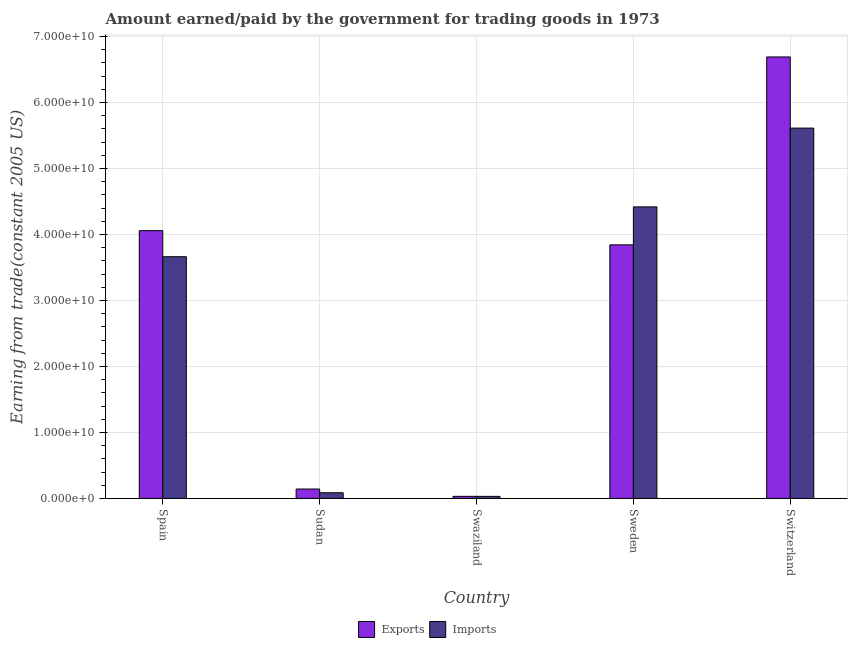How many different coloured bars are there?
Keep it short and to the point. 2. Are the number of bars per tick equal to the number of legend labels?
Keep it short and to the point. Yes. Are the number of bars on each tick of the X-axis equal?
Give a very brief answer. Yes. How many bars are there on the 4th tick from the left?
Make the answer very short. 2. What is the label of the 3rd group of bars from the left?
Offer a terse response. Swaziland. What is the amount earned from exports in Sweden?
Ensure brevity in your answer.  3.84e+1. Across all countries, what is the maximum amount earned from exports?
Your response must be concise. 6.69e+1. Across all countries, what is the minimum amount paid for imports?
Provide a short and direct response. 3.14e+08. In which country was the amount earned from exports maximum?
Offer a terse response. Switzerland. In which country was the amount earned from exports minimum?
Your answer should be very brief. Swaziland. What is the total amount earned from exports in the graph?
Your answer should be very brief. 1.48e+11. What is the difference between the amount earned from exports in Sweden and that in Switzerland?
Provide a short and direct response. -2.85e+1. What is the difference between the amount earned from exports in Sudan and the amount paid for imports in Switzerland?
Give a very brief answer. -5.47e+1. What is the average amount earned from exports per country?
Keep it short and to the point. 2.95e+1. What is the difference between the amount paid for imports and amount earned from exports in Spain?
Your response must be concise. -3.95e+09. In how many countries, is the amount paid for imports greater than 58000000000 US$?
Your answer should be very brief. 0. What is the ratio of the amount paid for imports in Sudan to that in Swaziland?
Give a very brief answer. 2.74. What is the difference between the highest and the second highest amount earned from exports?
Make the answer very short. 2.63e+1. What is the difference between the highest and the lowest amount paid for imports?
Your response must be concise. 5.58e+1. Is the sum of the amount paid for imports in Spain and Sudan greater than the maximum amount earned from exports across all countries?
Your answer should be very brief. No. What does the 1st bar from the left in Sudan represents?
Ensure brevity in your answer.  Exports. What does the 1st bar from the right in Sudan represents?
Ensure brevity in your answer.  Imports. How many bars are there?
Make the answer very short. 10. Are all the bars in the graph horizontal?
Give a very brief answer. No. Does the graph contain any zero values?
Provide a short and direct response. No. Where does the legend appear in the graph?
Provide a succinct answer. Bottom center. How are the legend labels stacked?
Offer a very short reply. Horizontal. What is the title of the graph?
Offer a terse response. Amount earned/paid by the government for trading goods in 1973. Does "Quasi money growth" appear as one of the legend labels in the graph?
Your answer should be very brief. No. What is the label or title of the X-axis?
Your answer should be compact. Country. What is the label or title of the Y-axis?
Your answer should be very brief. Earning from trade(constant 2005 US). What is the Earning from trade(constant 2005 US) in Exports in Spain?
Ensure brevity in your answer.  4.06e+1. What is the Earning from trade(constant 2005 US) of Imports in Spain?
Provide a succinct answer. 3.66e+1. What is the Earning from trade(constant 2005 US) of Exports in Sudan?
Your response must be concise. 1.43e+09. What is the Earning from trade(constant 2005 US) of Imports in Sudan?
Keep it short and to the point. 8.62e+08. What is the Earning from trade(constant 2005 US) in Exports in Swaziland?
Your answer should be very brief. 3.16e+08. What is the Earning from trade(constant 2005 US) in Imports in Swaziland?
Provide a succinct answer. 3.14e+08. What is the Earning from trade(constant 2005 US) in Exports in Sweden?
Offer a terse response. 3.84e+1. What is the Earning from trade(constant 2005 US) in Imports in Sweden?
Offer a very short reply. 4.42e+1. What is the Earning from trade(constant 2005 US) of Exports in Switzerland?
Your response must be concise. 6.69e+1. What is the Earning from trade(constant 2005 US) in Imports in Switzerland?
Ensure brevity in your answer.  5.61e+1. Across all countries, what is the maximum Earning from trade(constant 2005 US) of Exports?
Your response must be concise. 6.69e+1. Across all countries, what is the maximum Earning from trade(constant 2005 US) of Imports?
Ensure brevity in your answer.  5.61e+1. Across all countries, what is the minimum Earning from trade(constant 2005 US) of Exports?
Keep it short and to the point. 3.16e+08. Across all countries, what is the minimum Earning from trade(constant 2005 US) of Imports?
Your answer should be very brief. 3.14e+08. What is the total Earning from trade(constant 2005 US) of Exports in the graph?
Your answer should be very brief. 1.48e+11. What is the total Earning from trade(constant 2005 US) in Imports in the graph?
Offer a terse response. 1.38e+11. What is the difference between the Earning from trade(constant 2005 US) in Exports in Spain and that in Sudan?
Provide a short and direct response. 3.92e+1. What is the difference between the Earning from trade(constant 2005 US) of Imports in Spain and that in Sudan?
Offer a terse response. 3.58e+1. What is the difference between the Earning from trade(constant 2005 US) in Exports in Spain and that in Swaziland?
Your response must be concise. 4.03e+1. What is the difference between the Earning from trade(constant 2005 US) in Imports in Spain and that in Swaziland?
Make the answer very short. 3.63e+1. What is the difference between the Earning from trade(constant 2005 US) in Exports in Spain and that in Sweden?
Provide a succinct answer. 2.15e+09. What is the difference between the Earning from trade(constant 2005 US) of Imports in Spain and that in Sweden?
Ensure brevity in your answer.  -7.56e+09. What is the difference between the Earning from trade(constant 2005 US) in Exports in Spain and that in Switzerland?
Your answer should be compact. -2.63e+1. What is the difference between the Earning from trade(constant 2005 US) of Imports in Spain and that in Switzerland?
Ensure brevity in your answer.  -1.95e+1. What is the difference between the Earning from trade(constant 2005 US) in Exports in Sudan and that in Swaziland?
Provide a short and direct response. 1.11e+09. What is the difference between the Earning from trade(constant 2005 US) in Imports in Sudan and that in Swaziland?
Give a very brief answer. 5.48e+08. What is the difference between the Earning from trade(constant 2005 US) of Exports in Sudan and that in Sweden?
Your answer should be very brief. -3.70e+1. What is the difference between the Earning from trade(constant 2005 US) in Imports in Sudan and that in Sweden?
Keep it short and to the point. -4.33e+1. What is the difference between the Earning from trade(constant 2005 US) of Exports in Sudan and that in Switzerland?
Offer a terse response. -6.55e+1. What is the difference between the Earning from trade(constant 2005 US) of Imports in Sudan and that in Switzerland?
Give a very brief answer. -5.53e+1. What is the difference between the Earning from trade(constant 2005 US) of Exports in Swaziland and that in Sweden?
Keep it short and to the point. -3.81e+1. What is the difference between the Earning from trade(constant 2005 US) of Imports in Swaziland and that in Sweden?
Your answer should be very brief. -4.39e+1. What is the difference between the Earning from trade(constant 2005 US) of Exports in Swaziland and that in Switzerland?
Make the answer very short. -6.66e+1. What is the difference between the Earning from trade(constant 2005 US) of Imports in Swaziland and that in Switzerland?
Your answer should be very brief. -5.58e+1. What is the difference between the Earning from trade(constant 2005 US) in Exports in Sweden and that in Switzerland?
Provide a short and direct response. -2.85e+1. What is the difference between the Earning from trade(constant 2005 US) in Imports in Sweden and that in Switzerland?
Your answer should be compact. -1.19e+1. What is the difference between the Earning from trade(constant 2005 US) of Exports in Spain and the Earning from trade(constant 2005 US) of Imports in Sudan?
Your answer should be compact. 3.97e+1. What is the difference between the Earning from trade(constant 2005 US) in Exports in Spain and the Earning from trade(constant 2005 US) in Imports in Swaziland?
Provide a short and direct response. 4.03e+1. What is the difference between the Earning from trade(constant 2005 US) of Exports in Spain and the Earning from trade(constant 2005 US) of Imports in Sweden?
Offer a very short reply. -3.60e+09. What is the difference between the Earning from trade(constant 2005 US) in Exports in Spain and the Earning from trade(constant 2005 US) in Imports in Switzerland?
Your answer should be very brief. -1.55e+1. What is the difference between the Earning from trade(constant 2005 US) in Exports in Sudan and the Earning from trade(constant 2005 US) in Imports in Swaziland?
Your answer should be compact. 1.11e+09. What is the difference between the Earning from trade(constant 2005 US) of Exports in Sudan and the Earning from trade(constant 2005 US) of Imports in Sweden?
Offer a very short reply. -4.28e+1. What is the difference between the Earning from trade(constant 2005 US) in Exports in Sudan and the Earning from trade(constant 2005 US) in Imports in Switzerland?
Give a very brief answer. -5.47e+1. What is the difference between the Earning from trade(constant 2005 US) in Exports in Swaziland and the Earning from trade(constant 2005 US) in Imports in Sweden?
Give a very brief answer. -4.39e+1. What is the difference between the Earning from trade(constant 2005 US) of Exports in Swaziland and the Earning from trade(constant 2005 US) of Imports in Switzerland?
Make the answer very short. -5.58e+1. What is the difference between the Earning from trade(constant 2005 US) in Exports in Sweden and the Earning from trade(constant 2005 US) in Imports in Switzerland?
Keep it short and to the point. -1.77e+1. What is the average Earning from trade(constant 2005 US) in Exports per country?
Offer a terse response. 2.95e+1. What is the average Earning from trade(constant 2005 US) of Imports per country?
Ensure brevity in your answer.  2.76e+1. What is the difference between the Earning from trade(constant 2005 US) in Exports and Earning from trade(constant 2005 US) in Imports in Spain?
Offer a very short reply. 3.95e+09. What is the difference between the Earning from trade(constant 2005 US) of Exports and Earning from trade(constant 2005 US) of Imports in Sudan?
Your response must be concise. 5.64e+08. What is the difference between the Earning from trade(constant 2005 US) in Exports and Earning from trade(constant 2005 US) in Imports in Swaziland?
Your response must be concise. 2.54e+06. What is the difference between the Earning from trade(constant 2005 US) of Exports and Earning from trade(constant 2005 US) of Imports in Sweden?
Keep it short and to the point. -5.75e+09. What is the difference between the Earning from trade(constant 2005 US) in Exports and Earning from trade(constant 2005 US) in Imports in Switzerland?
Give a very brief answer. 1.08e+1. What is the ratio of the Earning from trade(constant 2005 US) in Exports in Spain to that in Sudan?
Provide a succinct answer. 28.46. What is the ratio of the Earning from trade(constant 2005 US) in Imports in Spain to that in Sudan?
Make the answer very short. 42.51. What is the ratio of the Earning from trade(constant 2005 US) in Exports in Spain to that in Swaziland?
Your response must be concise. 128.24. What is the ratio of the Earning from trade(constant 2005 US) in Imports in Spain to that in Swaziland?
Your response must be concise. 116.69. What is the ratio of the Earning from trade(constant 2005 US) of Exports in Spain to that in Sweden?
Your answer should be compact. 1.06. What is the ratio of the Earning from trade(constant 2005 US) in Imports in Spain to that in Sweden?
Give a very brief answer. 0.83. What is the ratio of the Earning from trade(constant 2005 US) of Exports in Spain to that in Switzerland?
Offer a very short reply. 0.61. What is the ratio of the Earning from trade(constant 2005 US) of Imports in Spain to that in Switzerland?
Give a very brief answer. 0.65. What is the ratio of the Earning from trade(constant 2005 US) of Exports in Sudan to that in Swaziland?
Your answer should be compact. 4.51. What is the ratio of the Earning from trade(constant 2005 US) in Imports in Sudan to that in Swaziland?
Your answer should be very brief. 2.74. What is the ratio of the Earning from trade(constant 2005 US) in Exports in Sudan to that in Sweden?
Offer a very short reply. 0.04. What is the ratio of the Earning from trade(constant 2005 US) of Imports in Sudan to that in Sweden?
Provide a short and direct response. 0.02. What is the ratio of the Earning from trade(constant 2005 US) of Exports in Sudan to that in Switzerland?
Make the answer very short. 0.02. What is the ratio of the Earning from trade(constant 2005 US) in Imports in Sudan to that in Switzerland?
Keep it short and to the point. 0.02. What is the ratio of the Earning from trade(constant 2005 US) of Exports in Swaziland to that in Sweden?
Provide a succinct answer. 0.01. What is the ratio of the Earning from trade(constant 2005 US) of Imports in Swaziland to that in Sweden?
Your response must be concise. 0.01. What is the ratio of the Earning from trade(constant 2005 US) of Exports in Swaziland to that in Switzerland?
Offer a terse response. 0. What is the ratio of the Earning from trade(constant 2005 US) of Imports in Swaziland to that in Switzerland?
Your answer should be very brief. 0.01. What is the ratio of the Earning from trade(constant 2005 US) in Exports in Sweden to that in Switzerland?
Keep it short and to the point. 0.57. What is the ratio of the Earning from trade(constant 2005 US) of Imports in Sweden to that in Switzerland?
Keep it short and to the point. 0.79. What is the difference between the highest and the second highest Earning from trade(constant 2005 US) in Exports?
Provide a short and direct response. 2.63e+1. What is the difference between the highest and the second highest Earning from trade(constant 2005 US) of Imports?
Keep it short and to the point. 1.19e+1. What is the difference between the highest and the lowest Earning from trade(constant 2005 US) in Exports?
Keep it short and to the point. 6.66e+1. What is the difference between the highest and the lowest Earning from trade(constant 2005 US) in Imports?
Ensure brevity in your answer.  5.58e+1. 